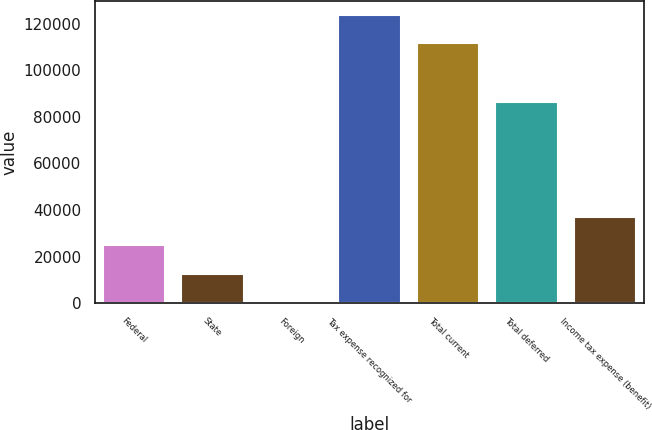Convert chart to OTSL. <chart><loc_0><loc_0><loc_500><loc_500><bar_chart><fcel>Federal<fcel>State<fcel>Foreign<fcel>Tax expense recognized for<fcel>Total current<fcel>Total deferred<fcel>Income tax expense (benefit)<nl><fcel>24835<fcel>12641.5<fcel>448<fcel>123724<fcel>111530<fcel>86199<fcel>37028.5<nl></chart> 